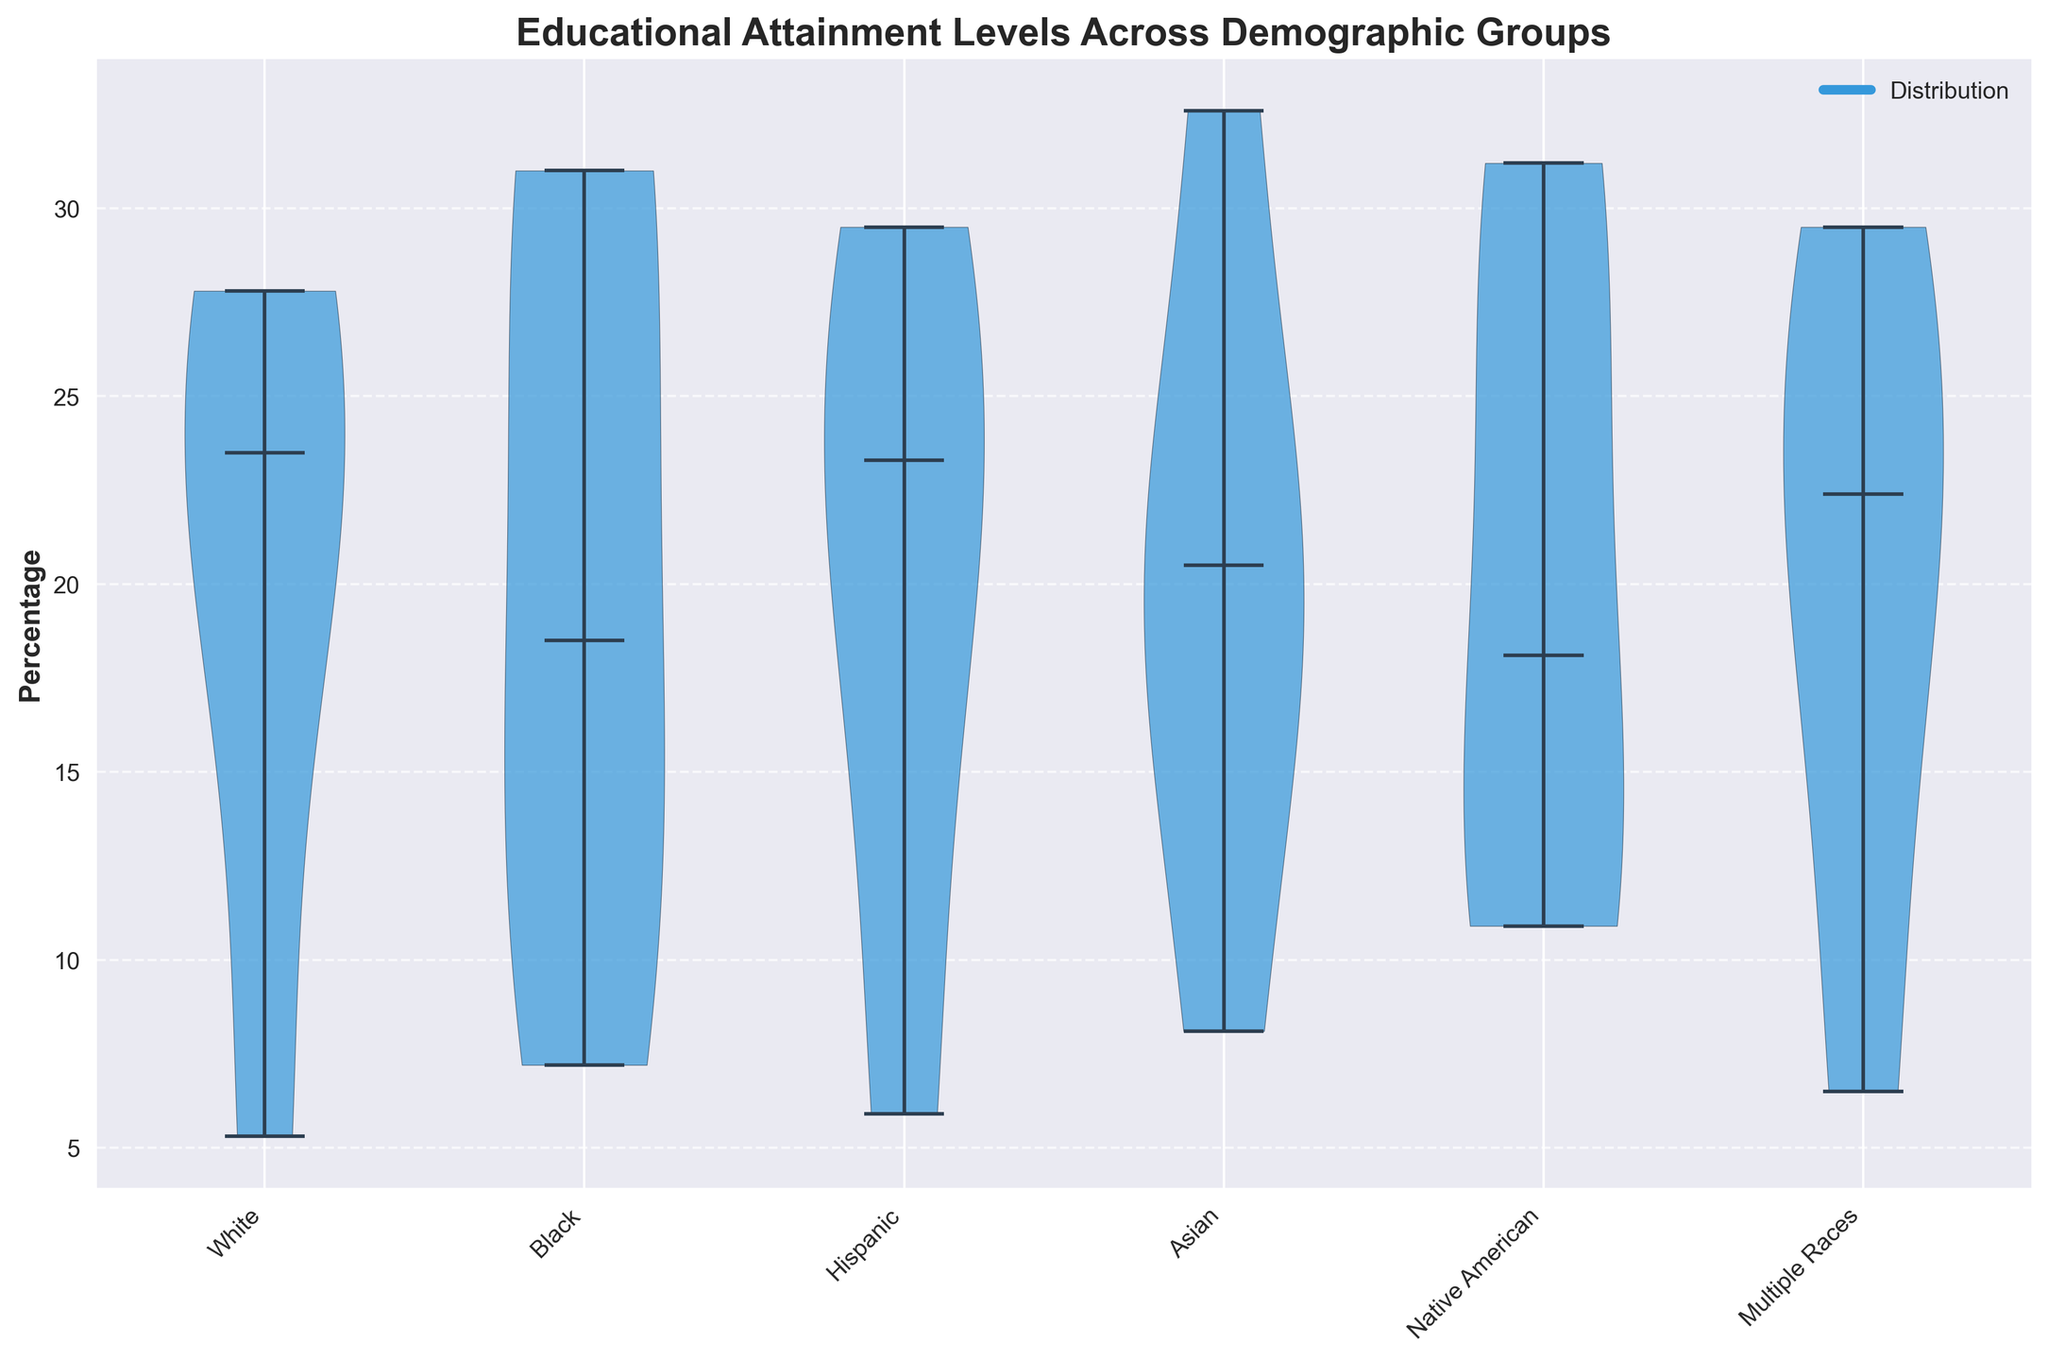Which demographic group has the highest median percentage in educational attainment? The median percentage is represented by the thick horizontal lines inside each violin shape. By visually inspecting each group, the Asian demographic group has the highest median value.
Answer: Asian What is the title of the figure? The title is displayed at the top center of the figure. It reads "Educational Attainment Levels Across Demographic Groups."
Answer: Educational Attainment Levels Across Demographic Groups How does the percentage of Hispanics with 'Graduate or Professional Degree' compare to Asians with the same level of education? In the figure, the percentage of Hispanics with 'Graduate or Professional Degree' is visually shorter than that of Asians. Therefore, Asians have a higher percentage.
Answer: Asians have a higher percentage Which demographic group shows the widest distribution in the violin plot? The widest distribution can be identified by observing the width of the violin shapes. The Hispanic group exhibits the widest distribution.
Answer: Hispanic Among the 'Some College' educational level, which demographic group has the highest median percentage? In the violin plot, by checking the thick horizontal lines for 'Some College,' the Hispanic demographic group has the highest median value.
Answer: Hispanic What is the primary color used in the violin bodies? The primary color used to fill the violin shapes is a shade of blue.
Answer: Blue Compare the distribution of 'High School Graduate' education level between Black and Native American groups. Visually, the Black group's distribution for 'High School Graduate' extends higher than that of Native Americans. Therefore, Blacks have a higher median or central tendency.
Answer: Black has a higher median Which demographic group has the smallest median percentage for the 'Bachelor's Degree' level? The smallest median percentage, indicated by the shortest thick horizontal line in the violin plot for 'Bachelor's Degree,' belongs to the Hispanic group.
Answer: Hispanic Is the 'Less than High School' attainment level generally higher for Native Americans or Whites? By observing the violins for 'Less than High School' level, the Native American group has a generally higher percentage than the White group.
Answer: Native Americans How many groups are represented in the violin plot? By counting the distinct x-tick labels, which represent the demographic groups, there are six groups in the plot.
Answer: Six 